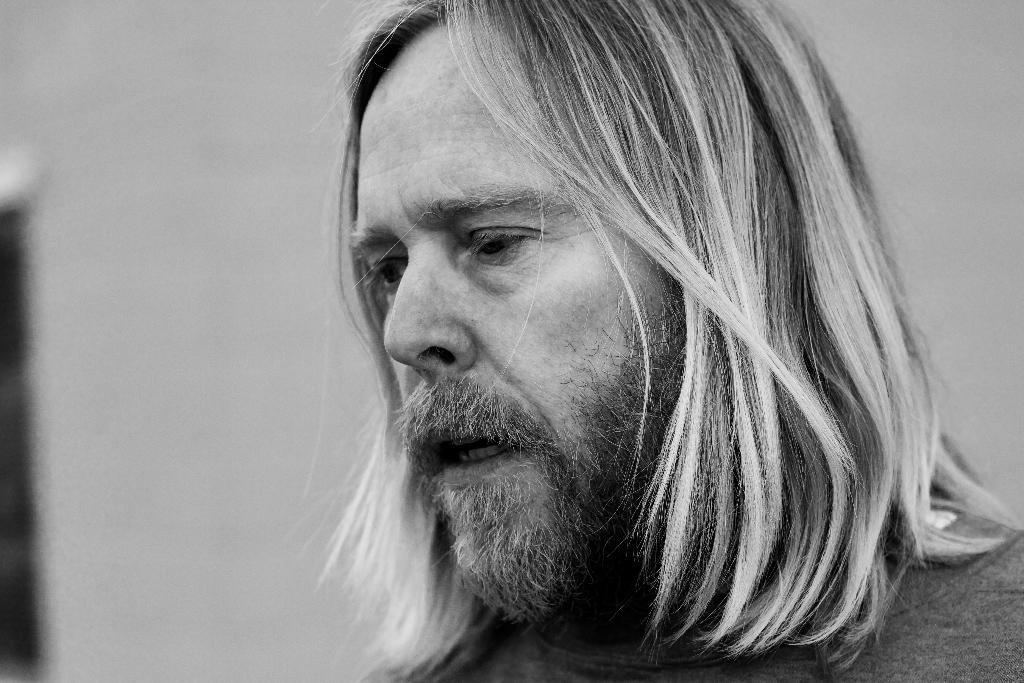What is present in the image? There is a man in the image. What is the color scheme of the image? The image is black and white. What type of paint is the man using to change the color of the range in the image? There is no paint, change, or range present in the image; it only features a man in a black and white setting. 